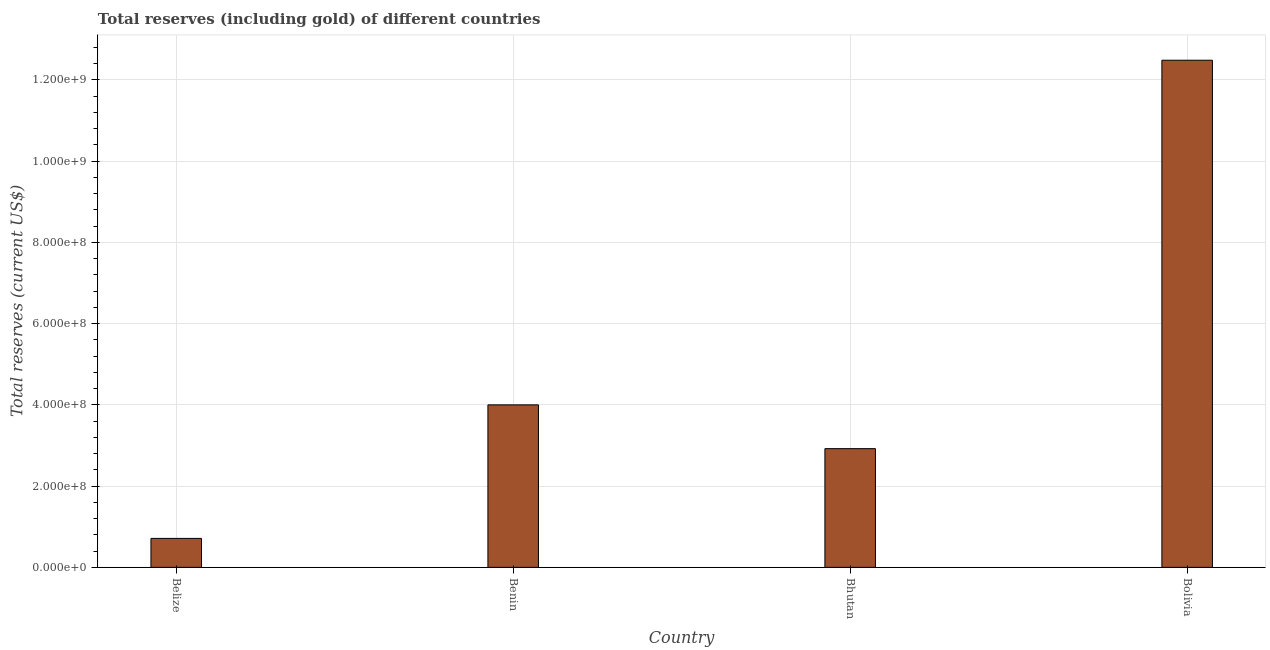What is the title of the graph?
Your answer should be very brief. Total reserves (including gold) of different countries. What is the label or title of the X-axis?
Your answer should be very brief. Country. What is the label or title of the Y-axis?
Provide a succinct answer. Total reserves (current US$). What is the total reserves (including gold) in Bhutan?
Your answer should be very brief. 2.92e+08. Across all countries, what is the maximum total reserves (including gold)?
Ensure brevity in your answer.  1.25e+09. Across all countries, what is the minimum total reserves (including gold)?
Offer a very short reply. 7.13e+07. In which country was the total reserves (including gold) maximum?
Your answer should be compact. Bolivia. In which country was the total reserves (including gold) minimum?
Provide a succinct answer. Belize. What is the sum of the total reserves (including gold)?
Keep it short and to the point. 2.01e+09. What is the difference between the total reserves (including gold) in Bhutan and Bolivia?
Keep it short and to the point. -9.56e+08. What is the average total reserves (including gold) per country?
Offer a terse response. 5.03e+08. What is the median total reserves (including gold)?
Give a very brief answer. 3.46e+08. What is the ratio of the total reserves (including gold) in Belize to that in Benin?
Give a very brief answer. 0.18. What is the difference between the highest and the second highest total reserves (including gold)?
Keep it short and to the point. 8.49e+08. Is the sum of the total reserves (including gold) in Belize and Bhutan greater than the maximum total reserves (including gold) across all countries?
Make the answer very short. No. What is the difference between the highest and the lowest total reserves (including gold)?
Give a very brief answer. 1.18e+09. In how many countries, is the total reserves (including gold) greater than the average total reserves (including gold) taken over all countries?
Ensure brevity in your answer.  1. How many bars are there?
Your answer should be very brief. 4. Are all the bars in the graph horizontal?
Provide a short and direct response. No. How many countries are there in the graph?
Ensure brevity in your answer.  4. What is the difference between two consecutive major ticks on the Y-axis?
Your answer should be very brief. 2.00e+08. Are the values on the major ticks of Y-axis written in scientific E-notation?
Provide a succinct answer. Yes. What is the Total reserves (current US$) in Belize?
Your answer should be very brief. 7.13e+07. What is the Total reserves (current US$) of Benin?
Your response must be concise. 4.00e+08. What is the Total reserves (current US$) of Bhutan?
Your answer should be very brief. 2.92e+08. What is the Total reserves (current US$) in Bolivia?
Your response must be concise. 1.25e+09. What is the difference between the Total reserves (current US$) in Belize and Benin?
Give a very brief answer. -3.29e+08. What is the difference between the Total reserves (current US$) in Belize and Bhutan?
Your answer should be compact. -2.21e+08. What is the difference between the Total reserves (current US$) in Belize and Bolivia?
Your response must be concise. -1.18e+09. What is the difference between the Total reserves (current US$) in Benin and Bhutan?
Make the answer very short. 1.08e+08. What is the difference between the Total reserves (current US$) in Benin and Bolivia?
Offer a very short reply. -8.49e+08. What is the difference between the Total reserves (current US$) in Bhutan and Bolivia?
Your answer should be compact. -9.56e+08. What is the ratio of the Total reserves (current US$) in Belize to that in Benin?
Keep it short and to the point. 0.18. What is the ratio of the Total reserves (current US$) in Belize to that in Bhutan?
Keep it short and to the point. 0.24. What is the ratio of the Total reserves (current US$) in Belize to that in Bolivia?
Make the answer very short. 0.06. What is the ratio of the Total reserves (current US$) in Benin to that in Bhutan?
Provide a short and direct response. 1.37. What is the ratio of the Total reserves (current US$) in Benin to that in Bolivia?
Your response must be concise. 0.32. What is the ratio of the Total reserves (current US$) in Bhutan to that in Bolivia?
Ensure brevity in your answer.  0.23. 